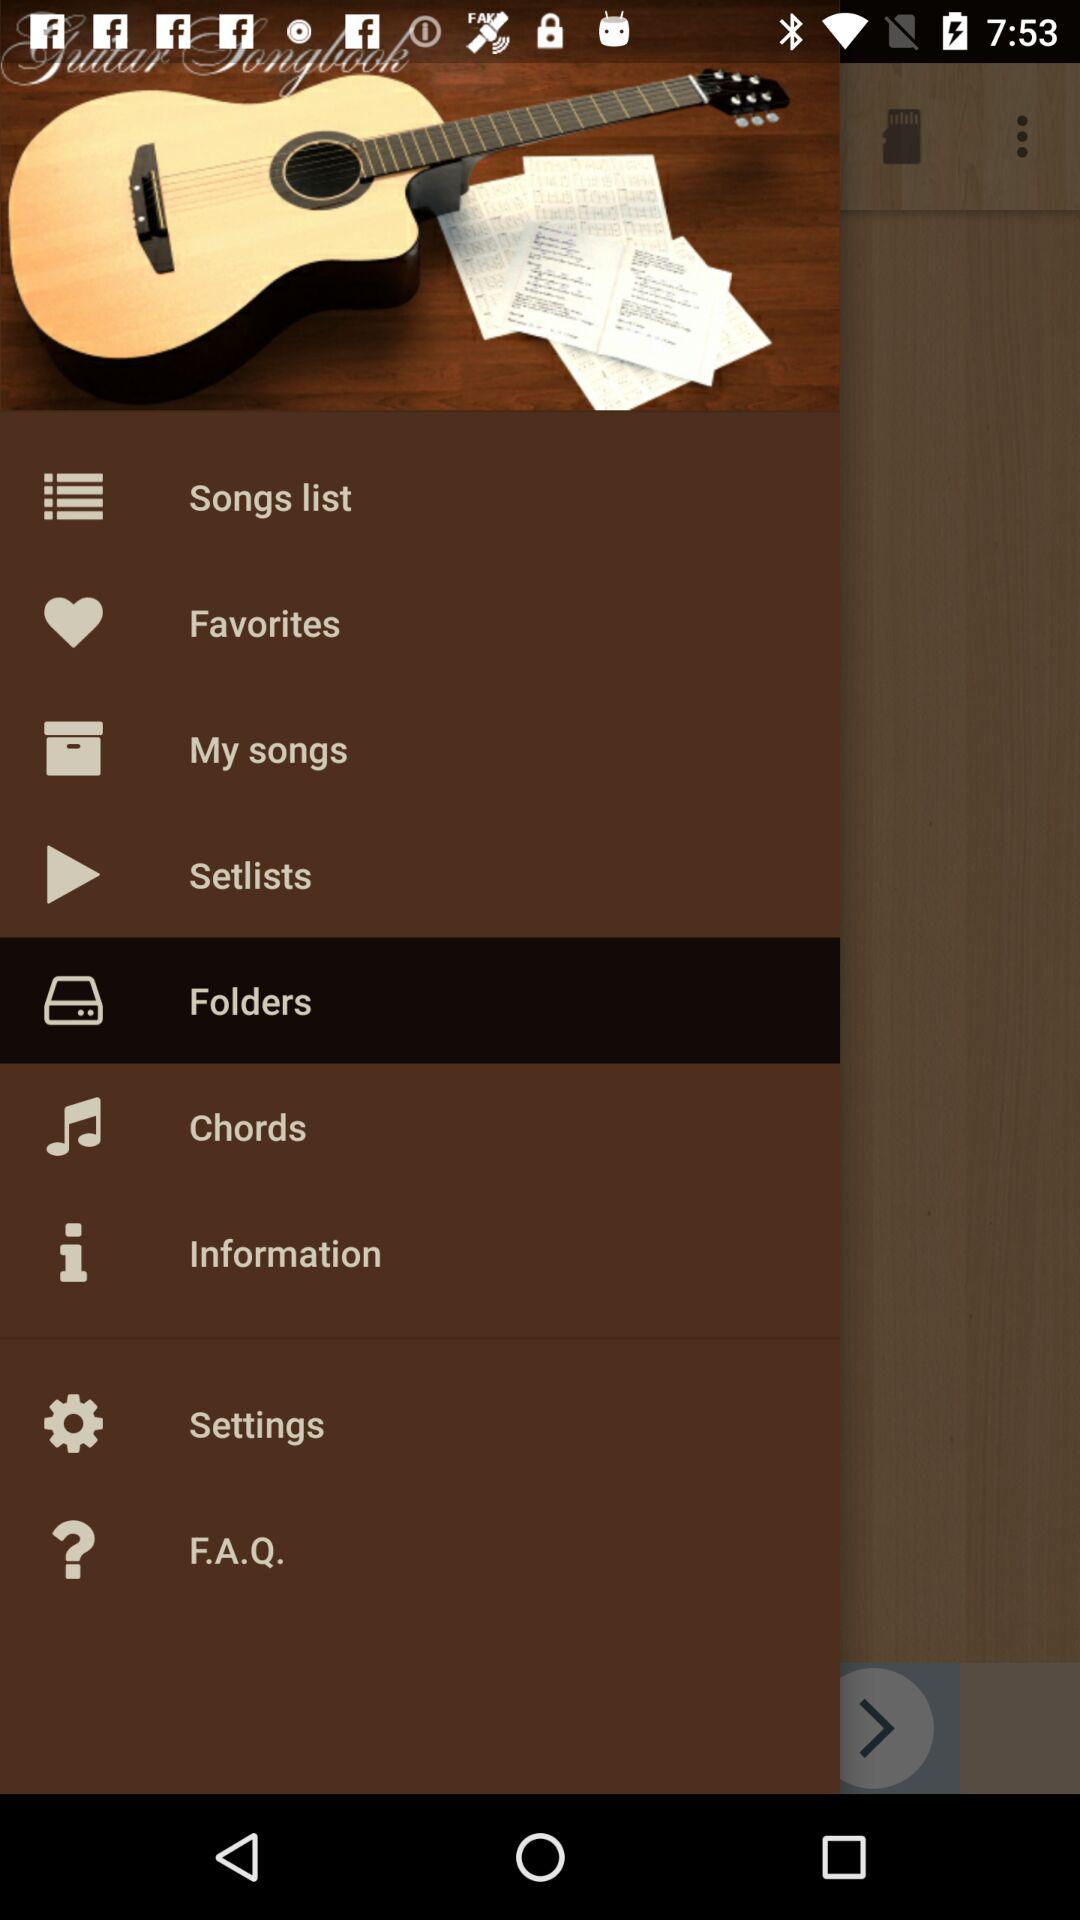Which item is currently selected? The item that is currently selected is "Folders". 